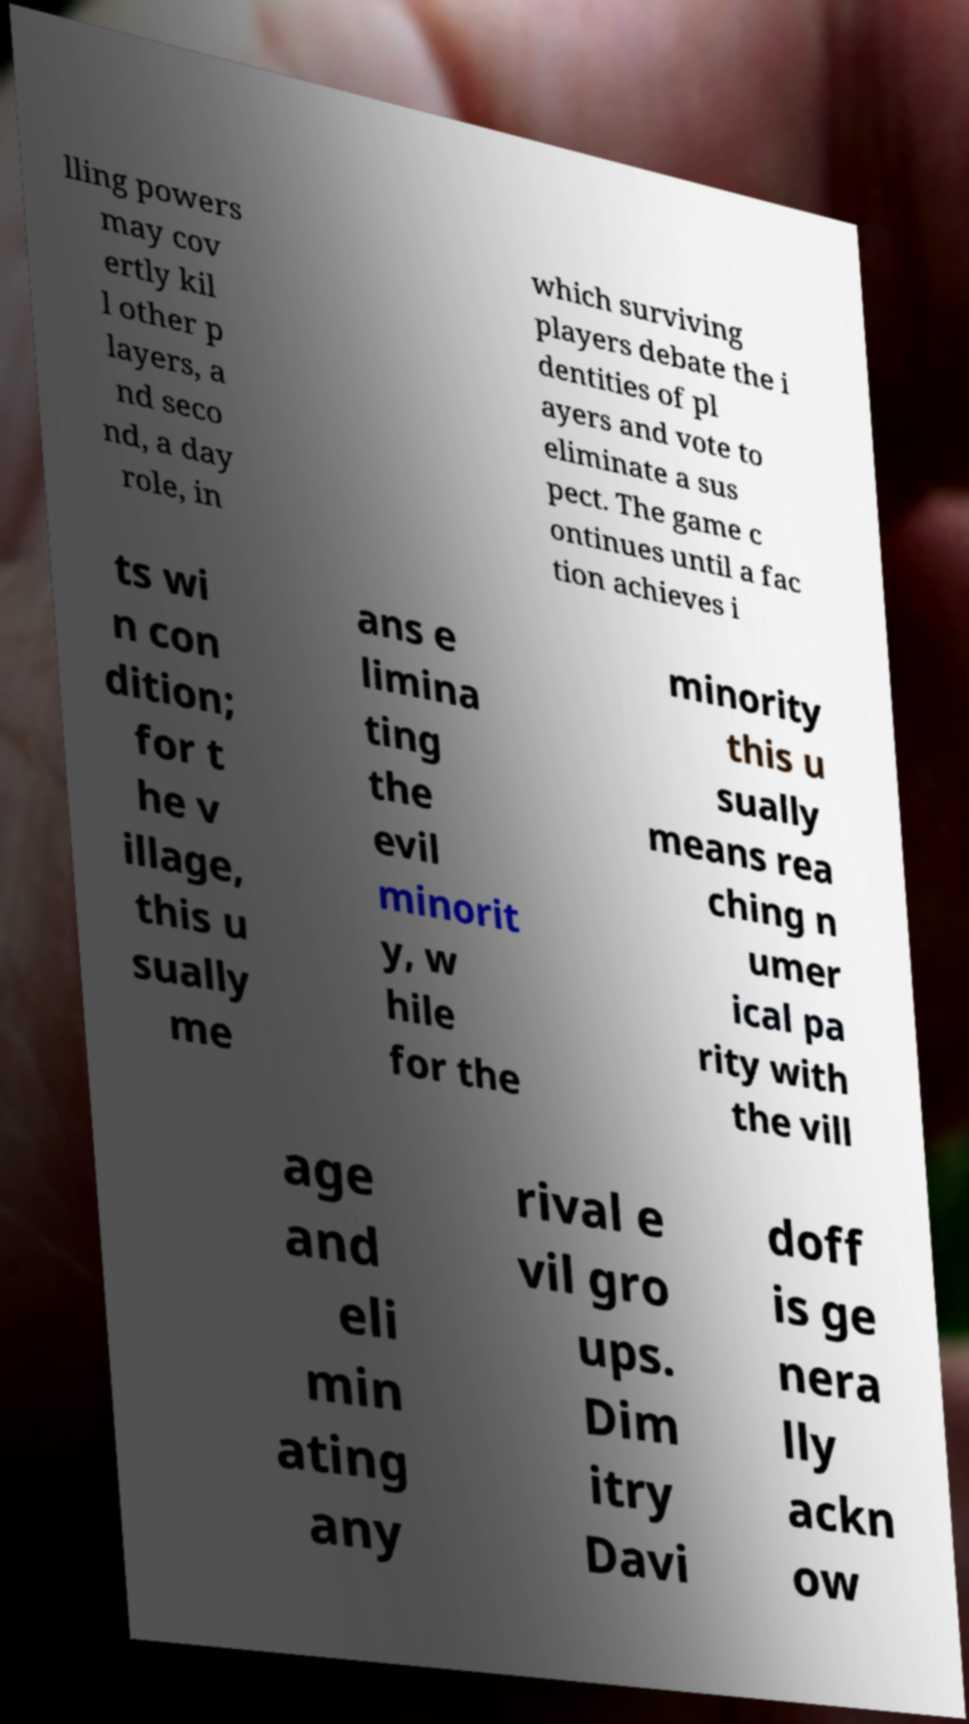I need the written content from this picture converted into text. Can you do that? lling powers may cov ertly kil l other p layers, a nd seco nd, a day role, in which surviving players debate the i dentities of pl ayers and vote to eliminate a sus pect. The game c ontinues until a fac tion achieves i ts wi n con dition; for t he v illage, this u sually me ans e limina ting the evil minorit y, w hile for the minority this u sually means rea ching n umer ical pa rity with the vill age and eli min ating any rival e vil gro ups. Dim itry Davi doff is ge nera lly ackn ow 